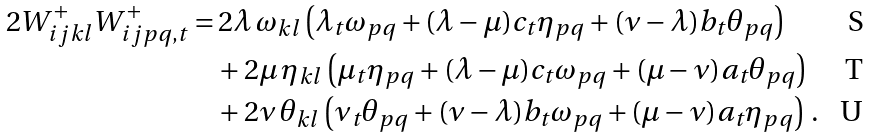Convert formula to latex. <formula><loc_0><loc_0><loc_500><loc_500>2 W ^ { + } _ { i j k l } W ^ { + } _ { i j p q , t } = & \, 2 \lambda \, \omega _ { k l } \left ( \lambda _ { t } \omega _ { p q } + ( \lambda - \mu ) c _ { t } \eta _ { p q } + ( \nu - \lambda ) b _ { t } \theta _ { p q } \right ) \\ & + 2 \mu \, \eta _ { k l } \left ( \mu _ { t } \eta _ { p q } + ( \lambda - \mu ) c _ { t } \omega _ { p q } + ( \mu - \nu ) a _ { t } \theta _ { p q } \right ) \\ & + 2 \nu \, \theta _ { k l } \left ( \nu _ { t } \theta _ { p q } + ( \nu - \lambda ) b _ { t } \omega _ { p q } + ( \mu - \nu ) a _ { t } \eta _ { p q } \right ) \, .</formula> 